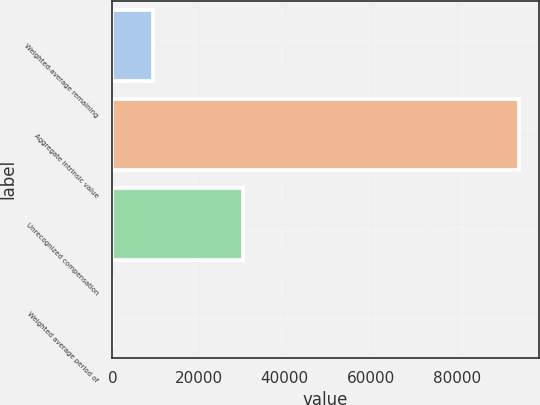Convert chart. <chart><loc_0><loc_0><loc_500><loc_500><bar_chart><fcel>Weighted-average remaining<fcel>Aggregate intrinsic value<fcel>Unrecognized compensation<fcel>Weighted average period of<nl><fcel>9428.51<fcel>94270<fcel>30299<fcel>1.68<nl></chart> 